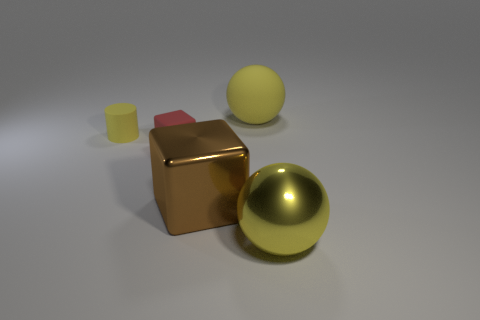How big is the yellow rubber object on the left side of the metal object that is to the left of the yellow sphere that is in front of the big brown thing?
Offer a very short reply. Small. There is another metallic object that is the same size as the brown shiny object; what shape is it?
Provide a succinct answer. Sphere. How many objects are yellow objects in front of the brown cube or large balls?
Keep it short and to the point. 2. Is there a small thing to the right of the tiny object behind the small object on the right side of the yellow cylinder?
Give a very brief answer. Yes. What number of brown metallic objects are there?
Ensure brevity in your answer.  1. How many objects are large objects in front of the big block or things that are behind the red rubber thing?
Provide a succinct answer. 3. Is the size of the sphere in front of the brown shiny object the same as the big brown metallic thing?
Keep it short and to the point. Yes. The brown thing that is the same shape as the red object is what size?
Make the answer very short. Large. There is another ball that is the same size as the yellow metal ball; what is its material?
Provide a succinct answer. Rubber. What material is the other yellow thing that is the same shape as the big matte object?
Provide a short and direct response. Metal. 